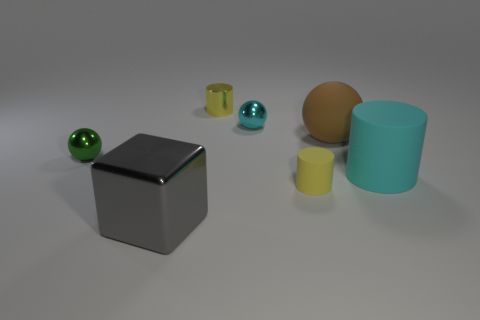Can you describe the textures of the different objects shown? Certainly! The large brown sphere has a smooth, perhaps matte, finish indicative of a surface like plastic or rubber. The cyan cylinder appears to have a similar matte finish, suggesting a non-metallic material. The two small spheres, one green and one blue, have reflective surfaces, which imply they could be made of polished metal or glass. Lastly, the large silver cube stands out with its highly reflective, almost mirror-like surface, consistent with a metallic texture. 